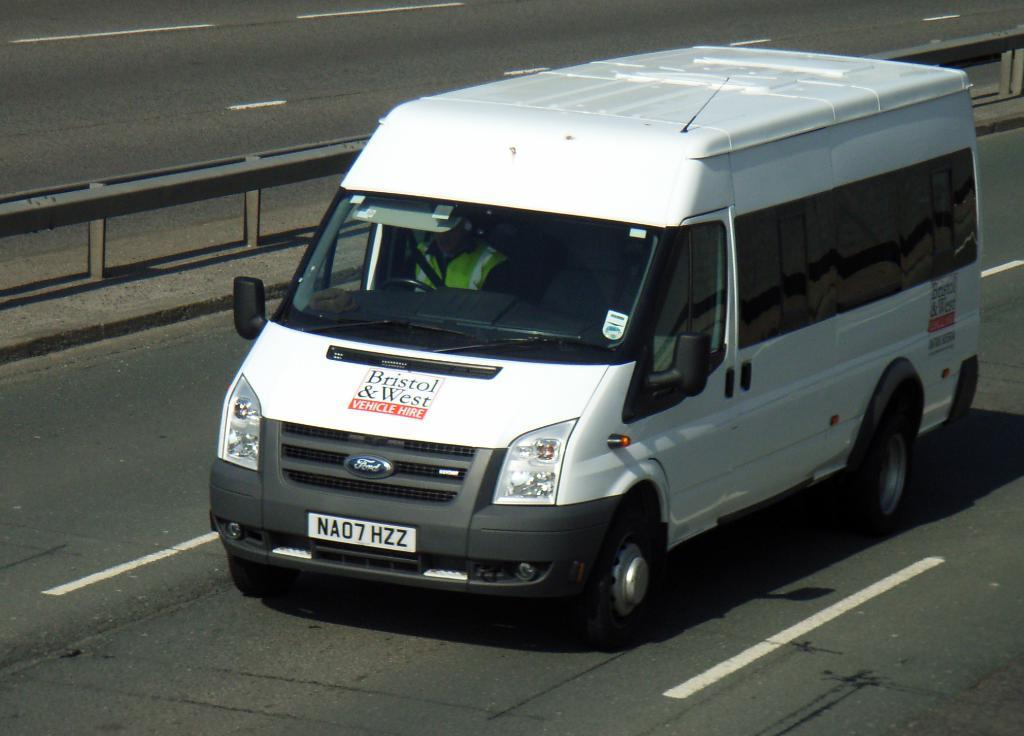<image>
Give a short and clear explanation of the subsequent image. A white cargo van with a sign on the hood that says "Bristol & West Vehicle Hire". 